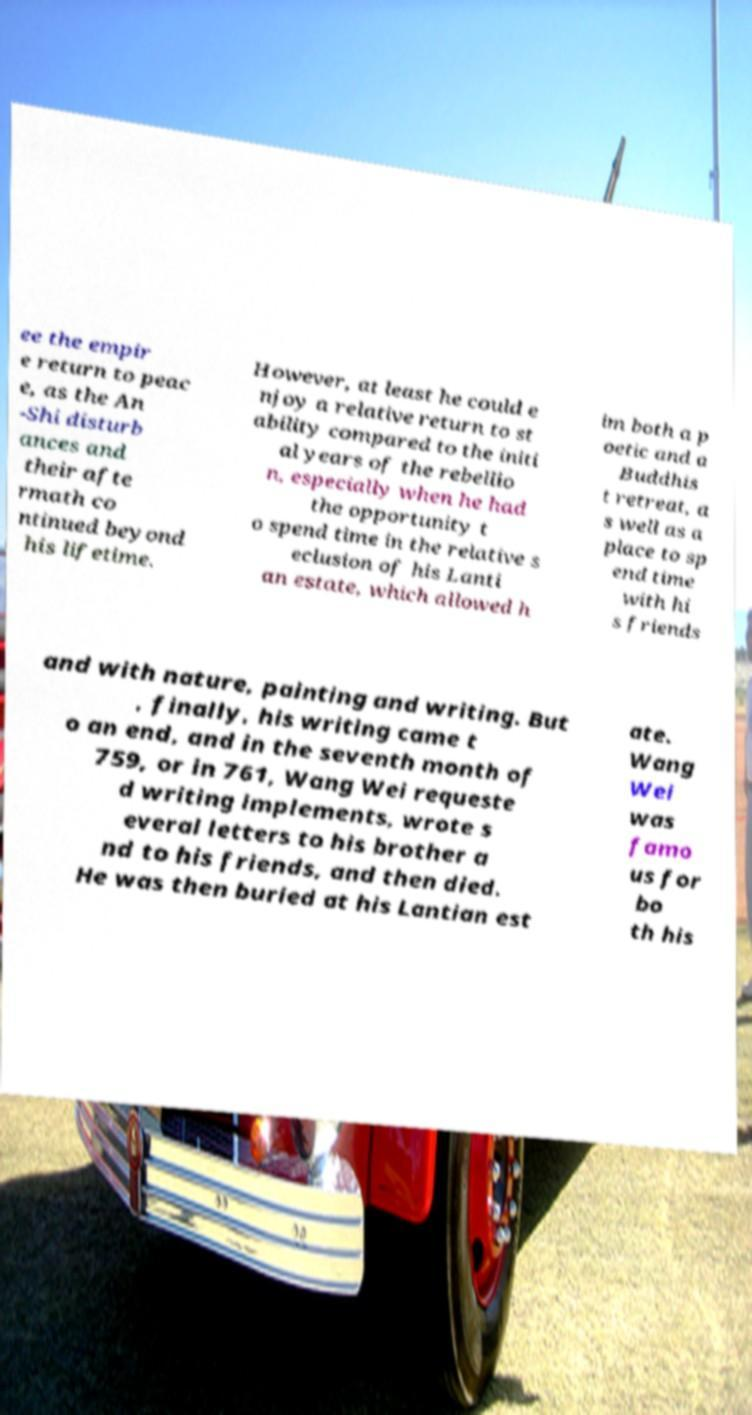What messages or text are displayed in this image? I need them in a readable, typed format. ee the empir e return to peac e, as the An -Shi disturb ances and their afte rmath co ntinued beyond his lifetime. However, at least he could e njoy a relative return to st ability compared to the initi al years of the rebellio n, especially when he had the opportunity t o spend time in the relative s eclusion of his Lanti an estate, which allowed h im both a p oetic and a Buddhis t retreat, a s well as a place to sp end time with hi s friends and with nature, painting and writing. But , finally, his writing came t o an end, and in the seventh month of 759, or in 761, Wang Wei requeste d writing implements, wrote s everal letters to his brother a nd to his friends, and then died. He was then buried at his Lantian est ate. Wang Wei was famo us for bo th his 